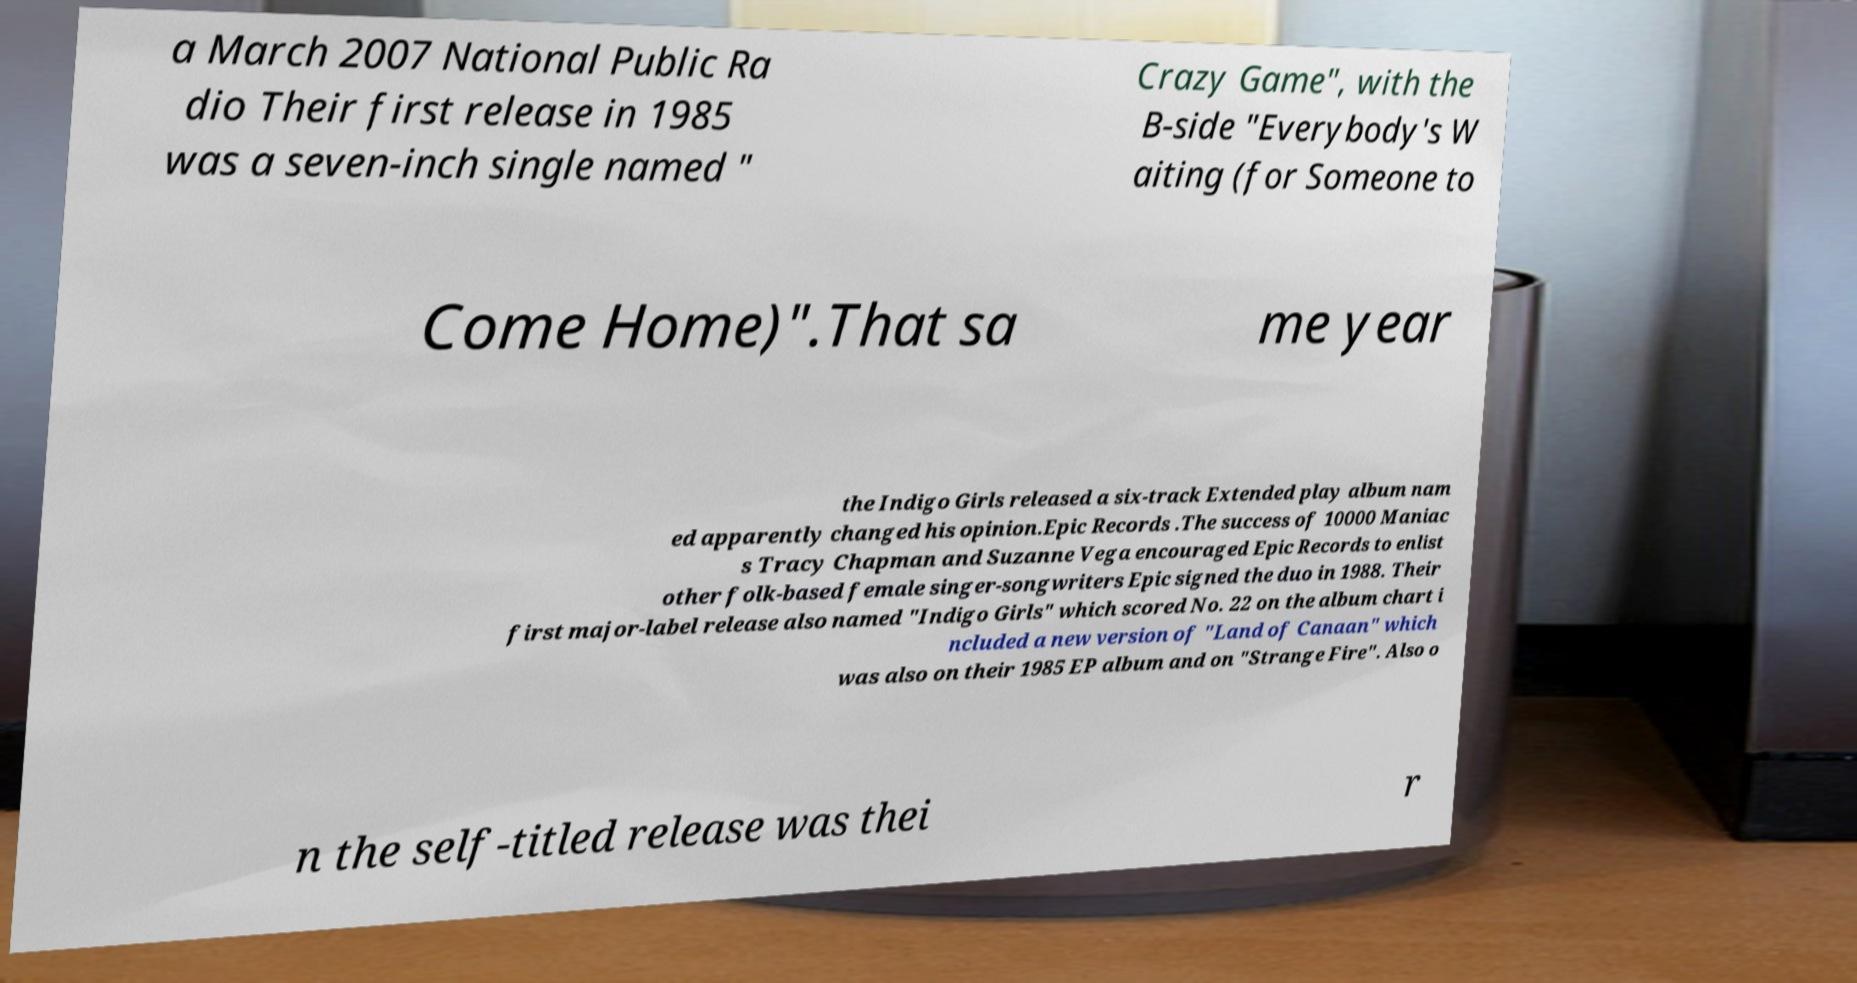Can you accurately transcribe the text from the provided image for me? a March 2007 National Public Ra dio Their first release in 1985 was a seven-inch single named " Crazy Game", with the B-side "Everybody's W aiting (for Someone to Come Home)".That sa me year the Indigo Girls released a six-track Extended play album nam ed apparently changed his opinion.Epic Records .The success of 10000 Maniac s Tracy Chapman and Suzanne Vega encouraged Epic Records to enlist other folk-based female singer-songwriters Epic signed the duo in 1988. Their first major-label release also named "Indigo Girls" which scored No. 22 on the album chart i ncluded a new version of "Land of Canaan" which was also on their 1985 EP album and on "Strange Fire". Also o n the self-titled release was thei r 